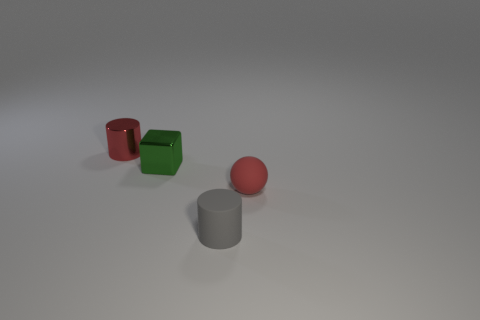There is a cylinder behind the cube; is its color the same as the small sphere?
Give a very brief answer. Yes. There is a cylinder that is the same color as the tiny ball; what material is it?
Keep it short and to the point. Metal. What number of metal things have the same color as the sphere?
Provide a short and direct response. 1. What is the size of the shiny cylinder that is the same color as the small rubber sphere?
Keep it short and to the point. Small. There is a object to the right of the gray cylinder; is its size the same as the gray cylinder in front of the tiny green thing?
Keep it short and to the point. Yes. What number of other objects are the same shape as the small green shiny object?
Keep it short and to the point. 0. There is a red thing to the right of the tiny cylinder on the left side of the gray matte object; what is it made of?
Offer a terse response. Rubber. What number of metallic objects are either gray cylinders or tiny objects?
Offer a terse response. 2. Are there any gray rubber things behind the red thing on the left side of the tiny ball?
Ensure brevity in your answer.  No. What number of objects are small things that are behind the tiny green shiny object or tiny objects right of the red shiny object?
Your answer should be compact. 4. 